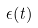<formula> <loc_0><loc_0><loc_500><loc_500>\epsilon ( t )</formula> 